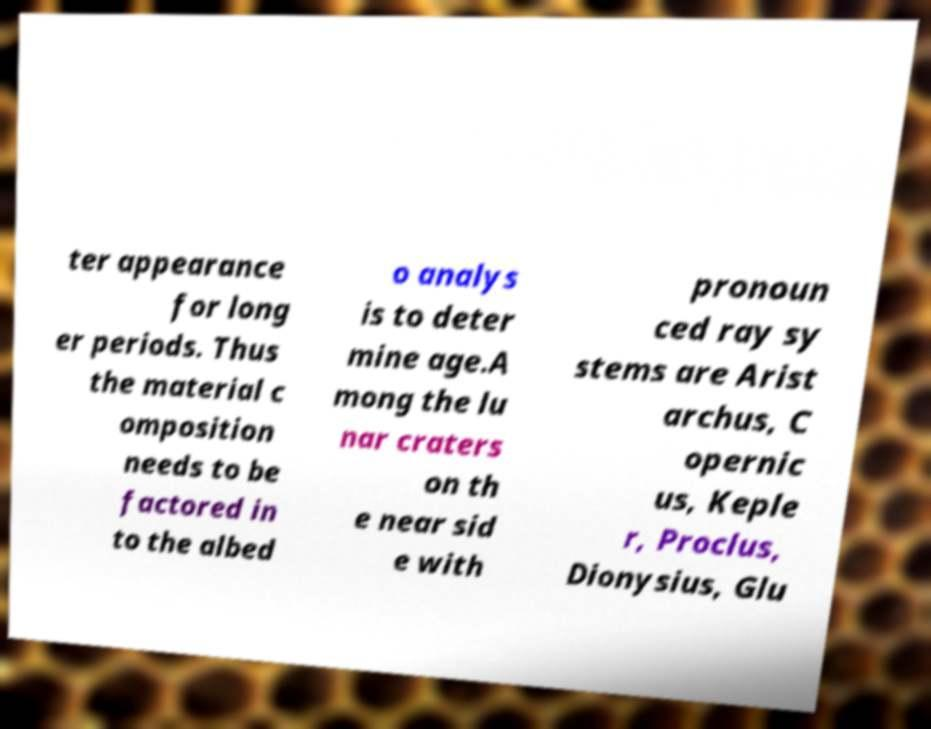Can you read and provide the text displayed in the image?This photo seems to have some interesting text. Can you extract and type it out for me? ter appearance for long er periods. Thus the material c omposition needs to be factored in to the albed o analys is to deter mine age.A mong the lu nar craters on th e near sid e with pronoun ced ray sy stems are Arist archus, C opernic us, Keple r, Proclus, Dionysius, Glu 